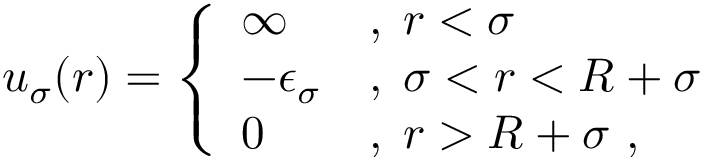<formula> <loc_0><loc_0><loc_500><loc_500>u _ { \sigma } ( r ) = \left \{ \begin{array} { l l } { \infty } & { , \, r < \sigma } \\ { - \epsilon _ { \sigma } } & { , \, \sigma < r < R + \sigma } \\ { 0 } & { , \, r > R + \sigma , } \end{array}</formula> 